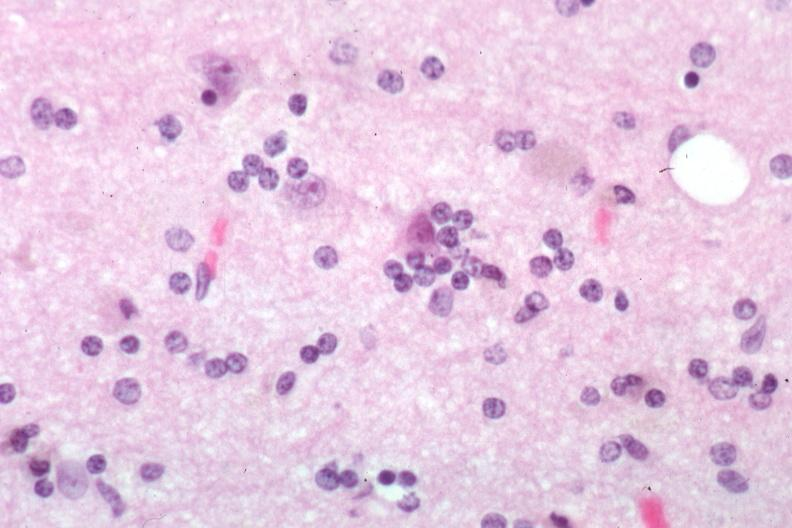what is present?
Answer the question using a single word or phrase. Neuronophagia 